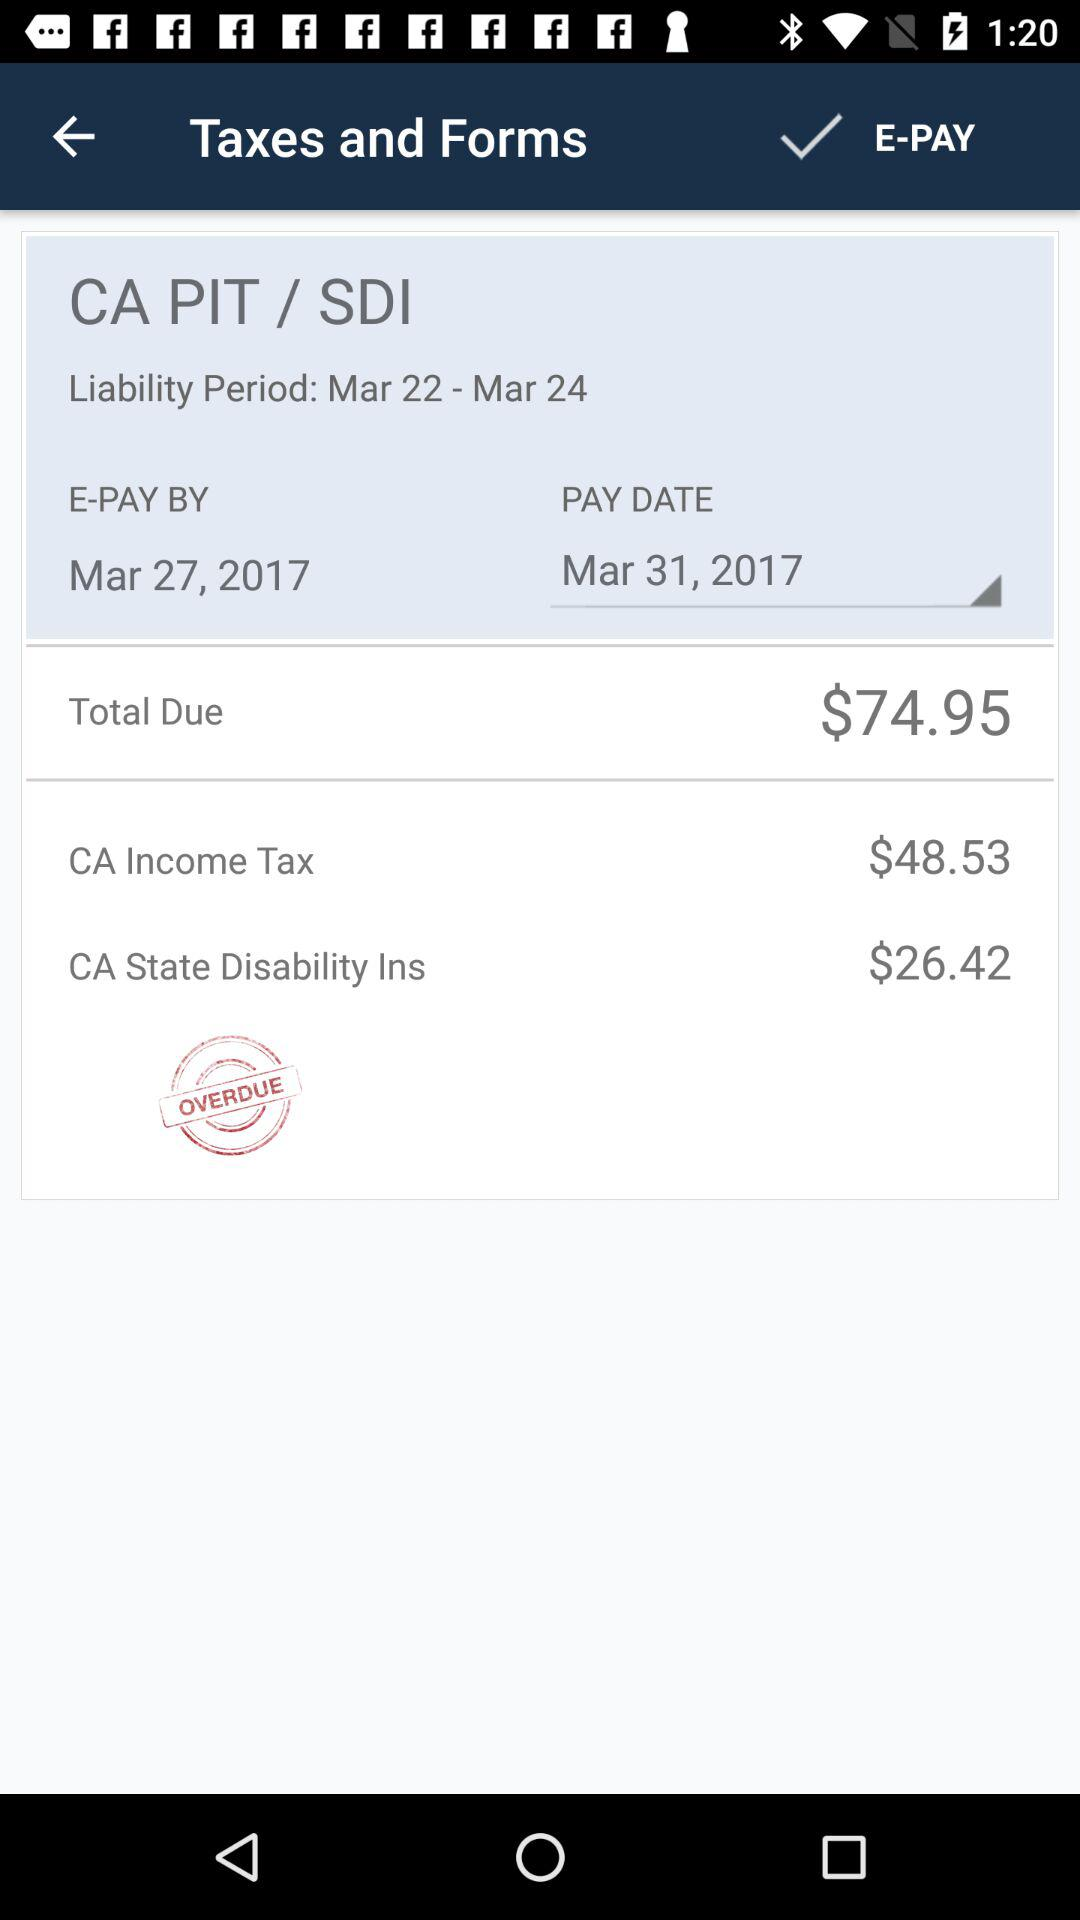How much is the total due?
Answer the question using a single word or phrase. $74.95 